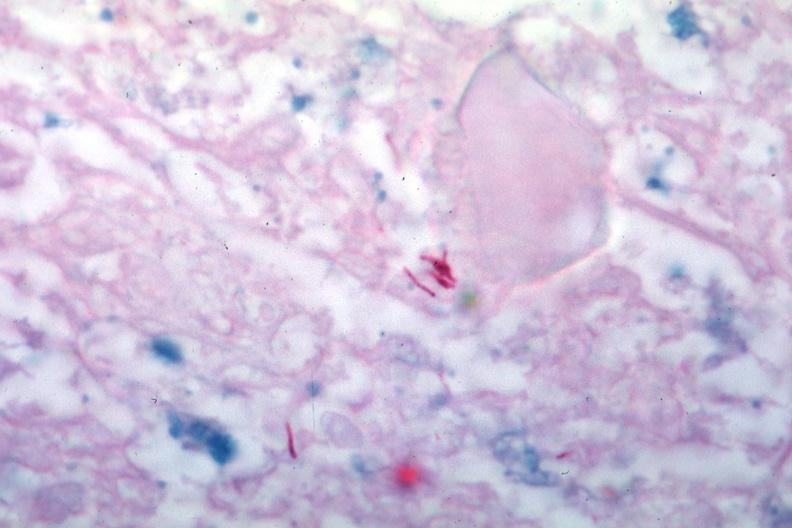what is present?
Answer the question using a single word or phrase. Lymph node 